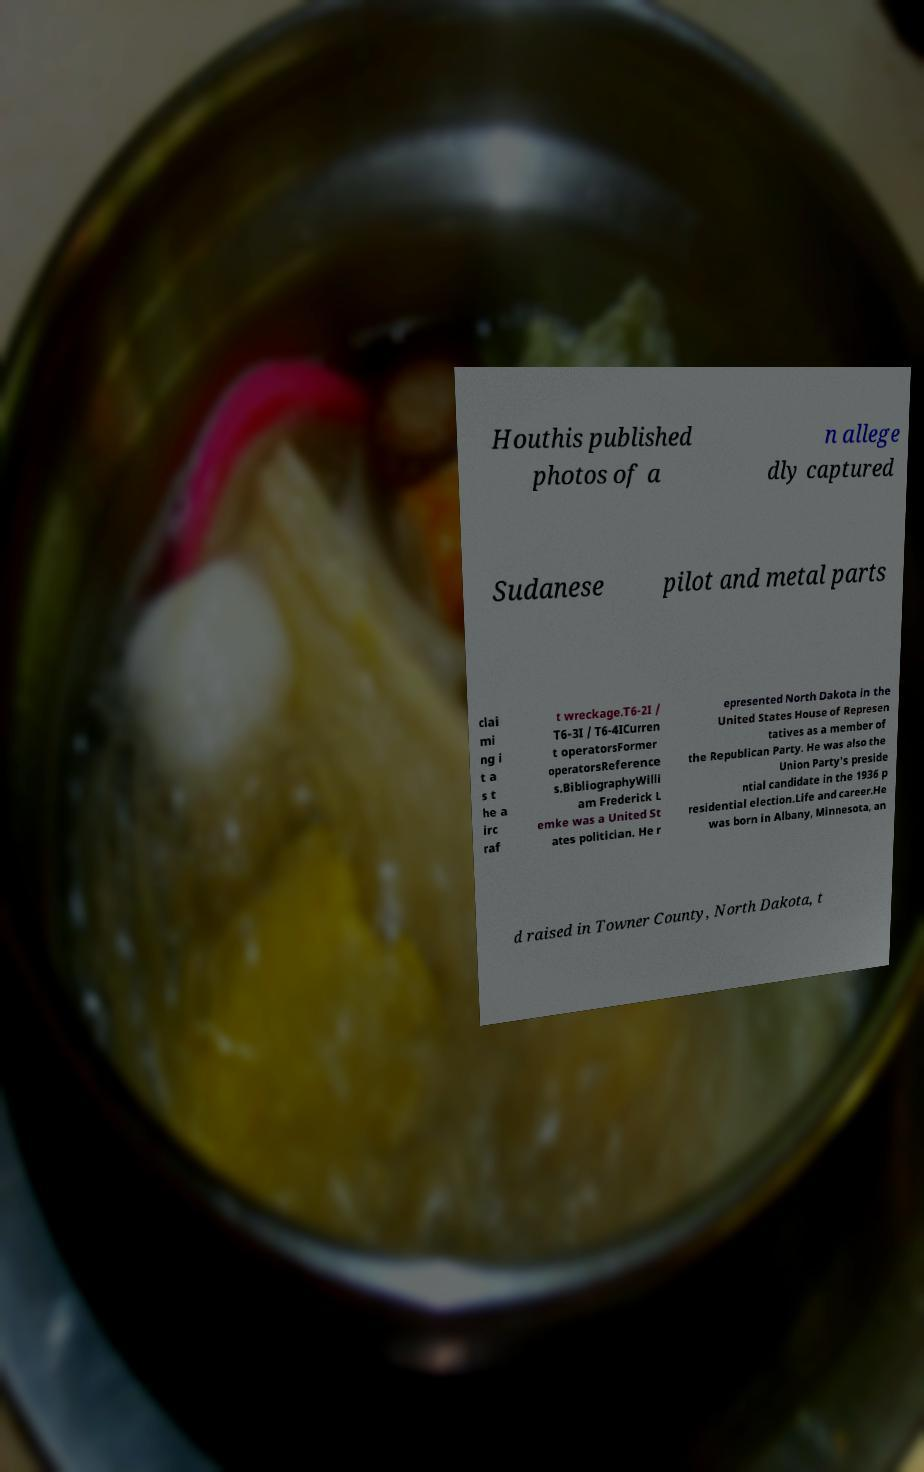What messages or text are displayed in this image? I need them in a readable, typed format. Houthis published photos of a n allege dly captured Sudanese pilot and metal parts clai mi ng i t a s t he a irc raf t wreckage.T6-2I / T6-3I / T6-4ICurren t operatorsFormer operatorsReference s.BibliographyWilli am Frederick L emke was a United St ates politician. He r epresented North Dakota in the United States House of Represen tatives as a member of the Republican Party. He was also the Union Party's preside ntial candidate in the 1936 p residential election.Life and career.He was born in Albany, Minnesota, an d raised in Towner County, North Dakota, t 